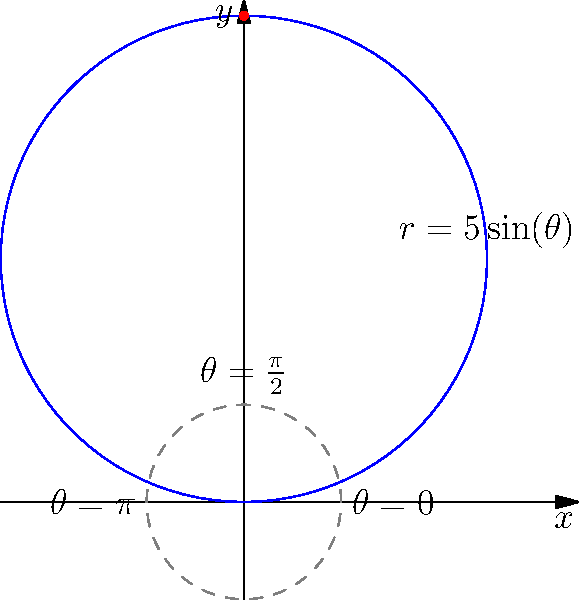In a Duke University women's basketball game, a player attempts a three-point shot. The trajectory of the ball can be modeled in polar coordinates by the equation $r = 5\sin(\theta)$, where $r$ is measured in feet and $\theta$ is in radians. At what angle $\theta$ does the ball reach its maximum height? To find the angle at which the ball reaches its maximum height, we need to follow these steps:

1) In polar coordinates, the maximum height occurs at the point furthest from the origin along the y-axis.

2) The y-coordinate in polar form is given by $y = r\sin(\theta)$.

3) Substituting our given equation: $y = 5\sin(\theta)\sin(\theta) = 5\sin^2(\theta)$.

4) To find the maximum value of $y$, we need to find where $\sin^2(\theta)$ is at its maximum.

5) $\sin^2(\theta)$ reaches its maximum value of 1 when $\sin(\theta) = 1$.

6) $\sin(\theta) = 1$ occurs when $\theta = \frac{\pi}{2}$ radians (or 90 degrees).

7) We can verify this by looking at the graph, where we see the highest point occurs at $\theta = \frac{\pi}{2}$.

Therefore, the ball reaches its maximum height when $\theta = \frac{\pi}{2}$ radians.
Answer: $\frac{\pi}{2}$ radians 